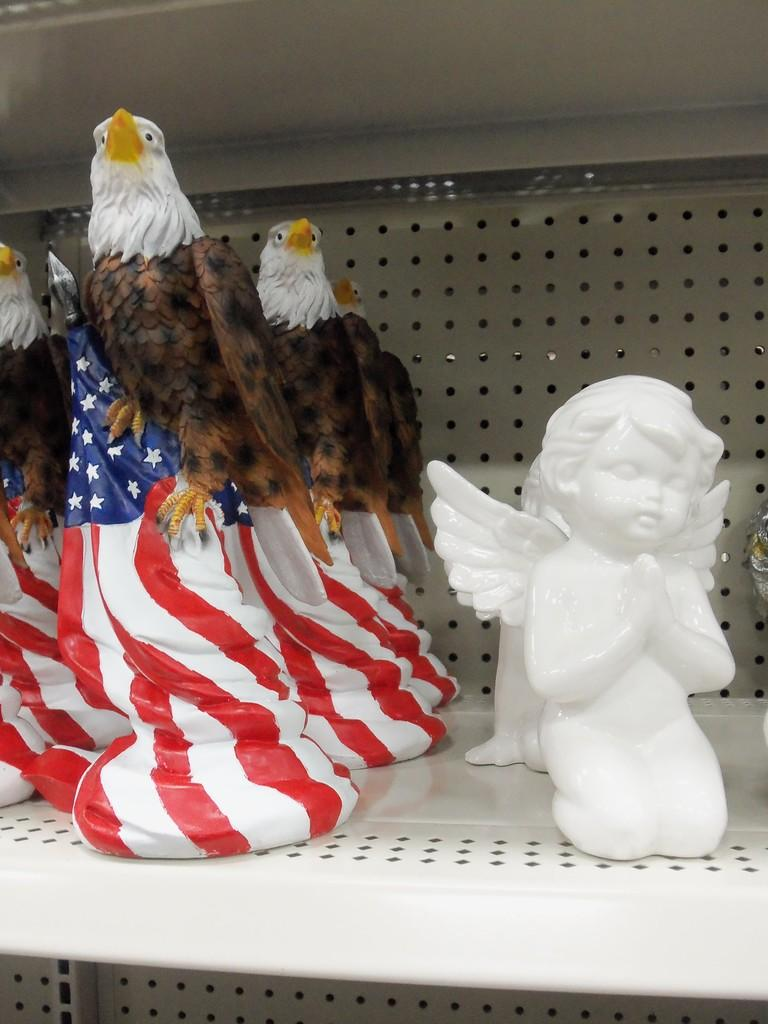What type of objects are present in the image? There are toy statues in the image. What type of grain is being used to make the basketball in the image? There is no basketball present in the image; it only features toy statues. 